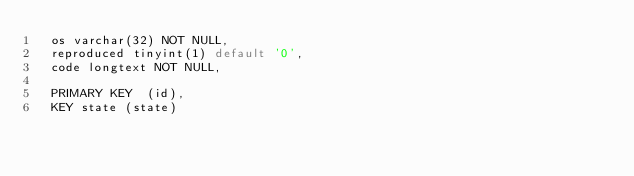Convert code to text. <code><loc_0><loc_0><loc_500><loc_500><_SQL_>  os varchar(32) NOT NULL,
  reproduced tinyint(1) default '0',
  code longtext NOT NULL,

  PRIMARY KEY  (id),
  KEY state (state)
</code> 